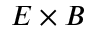Convert formula to latex. <formula><loc_0><loc_0><loc_500><loc_500>E \times B</formula> 